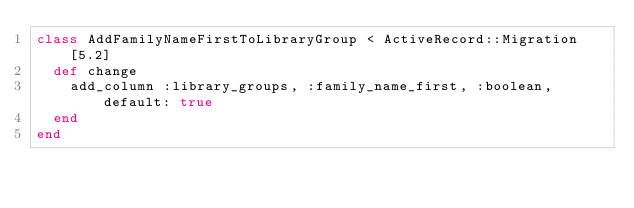Convert code to text. <code><loc_0><loc_0><loc_500><loc_500><_Ruby_>class AddFamilyNameFirstToLibraryGroup < ActiveRecord::Migration[5.2]
  def change
    add_column :library_groups, :family_name_first, :boolean, default: true
  end
end
</code> 